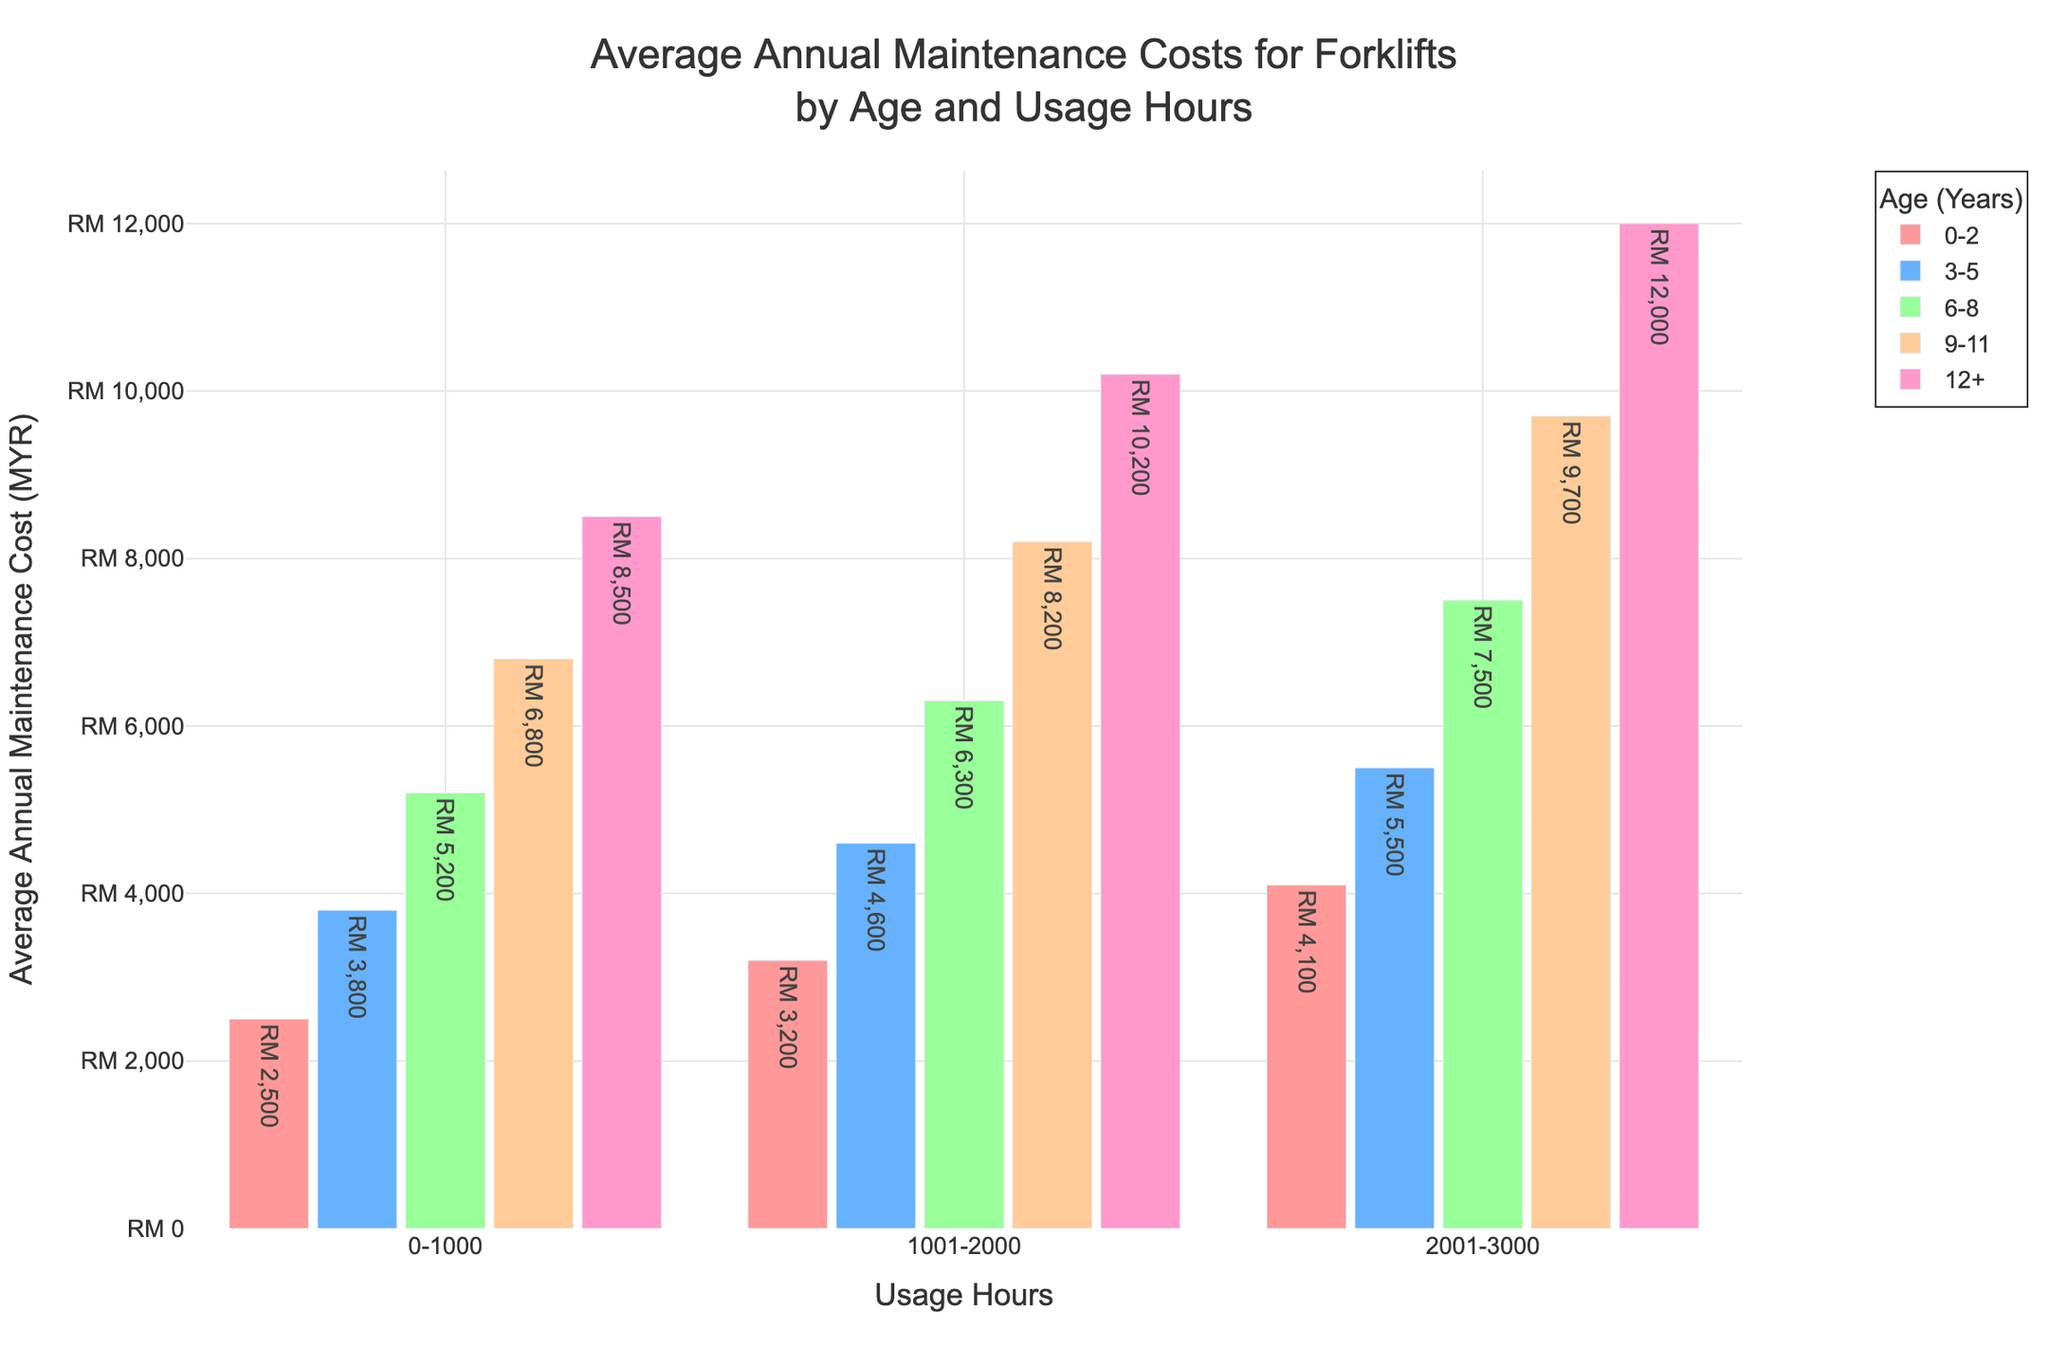What is the average annual maintenance cost for forklifts aged 6-8 years with 1001-2000 usage hours? Locate the bar representing forklifts aged 6-8 years and usage hours of 1001-2000. The maintenance cost is indicated on the top of the bar.
Answer: RM 6300 Which age group has the highest average annual maintenance cost for forklifts used between 2001-3000 hours? Look for the tallest bar among the bars representing 2001-3000 usage hours. Identify the corresponding age group from the legend.
Answer: 12+ years How does the average annual maintenance cost for forklifts aged 0-2 years and used 2001-3000 hours compare to those aged 3-5 years and used 0-1000 hours? Compare the heights of the bars for 0-2 years at 2001-3000 hours with the bar for 3-5 years at 0-1000 hours.
Answer: 4100 < 3800 What is the difference in average annual maintenance costs between forklifts aged 9-11 years with 0-1000 usage hours and those aged 12+ years with the same usage hours? Identify the bars for forklifts aged 9-11 years and 12+ years at 0-1000 usage hours. Subtract the maintenance cost of 9-11 years from the cost of 12+ years.
Answer: 8500 - 6800 = 1700 Which usage hour category shows the largest increase in average annual maintenance costs when comparing forklifts aged 3-5 years to those aged 6-8 years? Observe the increase in bar heights for all usage hour categories between the 3-5 years and 6-8 years age groups. Identify the category with the largest difference.
Answer: 0-1000 What is the total average annual maintenance cost for forklifts aged 9-11 years across all usage hour categories? Add the maintenance costs for forklifts aged 9-11 years across 0-1000 hours, 1001-2000 hours, and 2001-3000 hours.
Answer: 6800 + 8200 + 9700 = 24700 In which usage hours category does the average annual maintenance cost exceed RM 10000 and for which age groups? Scan all bars to find those exceeding RM 10000. Note the corresponding age groups and usage hour categories.
Answer: 12+ years at 1001-2000 and 2001-3000 hours 